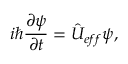Convert formula to latex. <formula><loc_0><loc_0><loc_500><loc_500>i \hbar { } \partial \psi } { \partial t } = \hat { U } _ { e f f } \psi ,</formula> 